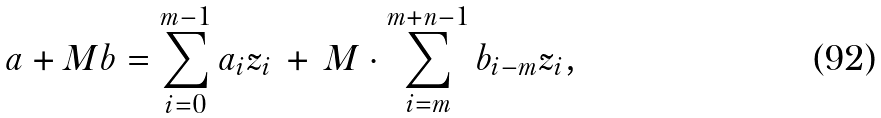<formula> <loc_0><loc_0><loc_500><loc_500>a + M b = \sum _ { i = 0 } ^ { m - 1 } a _ { i } z _ { i } \, + \, M \cdot \sum _ { i = m } ^ { m + n - 1 } b _ { i - m } z _ { i } ,</formula> 